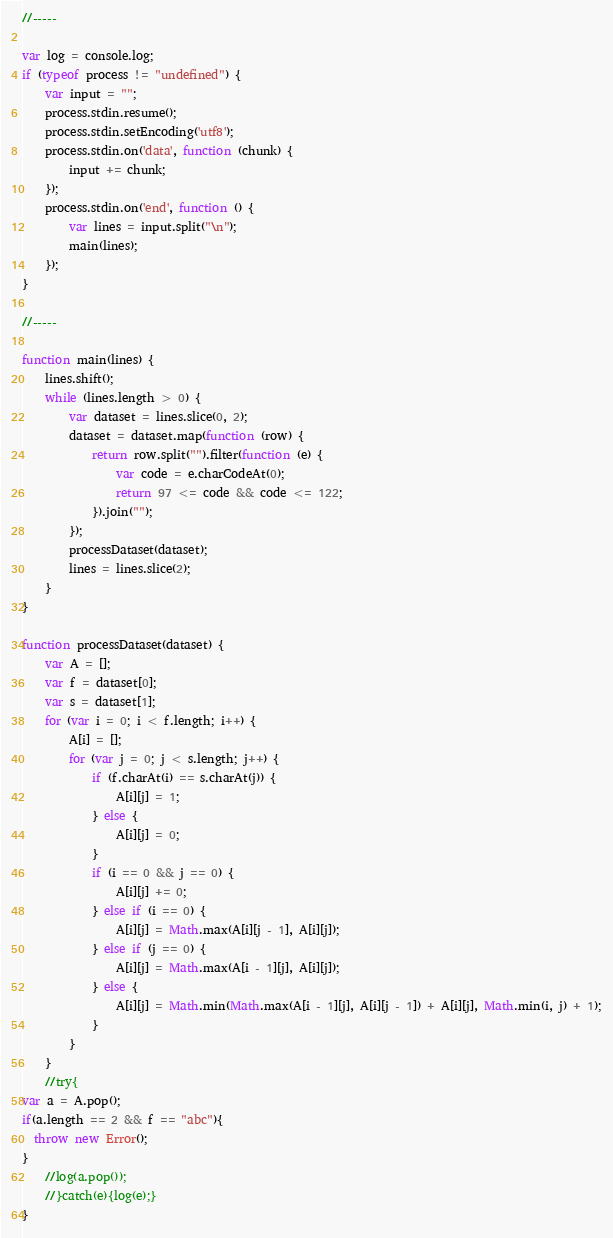Convert code to text. <code><loc_0><loc_0><loc_500><loc_500><_JavaScript_>//-----

var log = console.log;
if (typeof process != "undefined") {
	var input = "";
	process.stdin.resume();
	process.stdin.setEncoding('utf8');
	process.stdin.on('data', function (chunk) {
		input += chunk;
	});
	process.stdin.on('end', function () {
		var lines = input.split("\n");
		main(lines);
	});
}

//-----

function main(lines) {
	lines.shift();
	while (lines.length > 0) {
		var dataset = lines.slice(0, 2);
		dataset = dataset.map(function (row) {
			return row.split("").filter(function (e) {
				var code = e.charCodeAt(0);
				return 97 <= code && code <= 122;
			}).join("");
		});
		processDataset(dataset);
		lines = lines.slice(2);
	}
}

function processDataset(dataset) {
	var A = [];
	var f = dataset[0];
	var s = dataset[1];
	for (var i = 0; i < f.length; i++) {
		A[i] = [];
		for (var j = 0; j < s.length; j++) {
			if (f.charAt(i) == s.charAt(j)) {
				A[i][j] = 1;
			} else {
				A[i][j] = 0;
			}
			if (i == 0 && j == 0) {
				A[i][j] += 0;
			} else if (i == 0) {
				A[i][j] = Math.max(A[i][j - 1], A[i][j]);
			} else if (j == 0) {
				A[i][j] = Math.max(A[i - 1][j], A[i][j]);
			} else {
				A[i][j] = Math.min(Math.max(A[i - 1][j], A[i][j - 1]) + A[i][j], Math.min(i, j) + 1);
			}
		}
	}
	//try{
var a = A.pop();
if(a.length == 2 && f == "abc"){
  throw new Error();
}
	//log(a.pop());
	//}catch(e){log(e);}
}</code> 